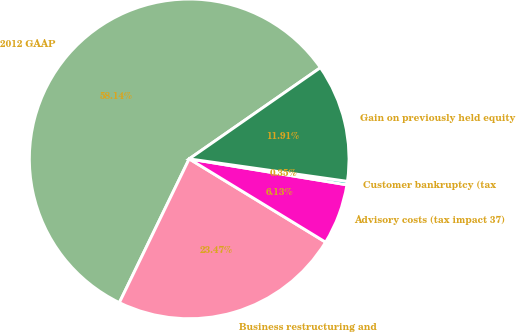Convert chart. <chart><loc_0><loc_0><loc_500><loc_500><pie_chart><fcel>2012 GAAP<fcel>Business restructuring and<fcel>Advisory costs (tax impact 37)<fcel>Customer bankruptcy (tax<fcel>Gain on previously held equity<nl><fcel>58.13%<fcel>23.47%<fcel>6.13%<fcel>0.35%<fcel>11.91%<nl></chart> 